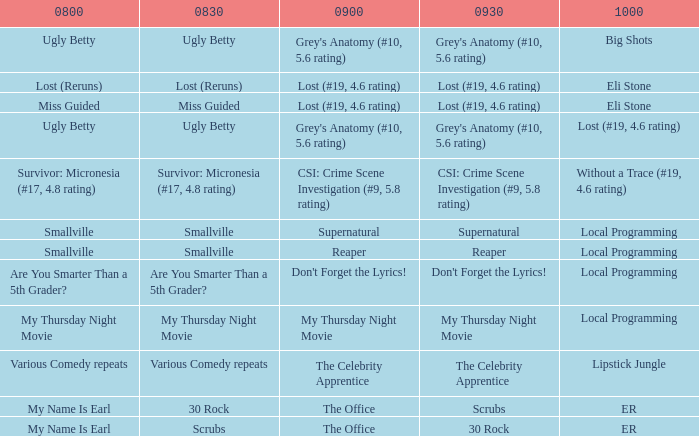What is at 9:30 when at 8:30 it is scrubs? 30 Rock. Could you parse the entire table as a dict? {'header': ['0800', '0830', '0900', '0930', '1000'], 'rows': [['Ugly Betty', 'Ugly Betty', "Grey's Anatomy (#10, 5.6 rating)", "Grey's Anatomy (#10, 5.6 rating)", 'Big Shots'], ['Lost (Reruns)', 'Lost (Reruns)', 'Lost (#19, 4.6 rating)', 'Lost (#19, 4.6 rating)', 'Eli Stone'], ['Miss Guided', 'Miss Guided', 'Lost (#19, 4.6 rating)', 'Lost (#19, 4.6 rating)', 'Eli Stone'], ['Ugly Betty', 'Ugly Betty', "Grey's Anatomy (#10, 5.6 rating)", "Grey's Anatomy (#10, 5.6 rating)", 'Lost (#19, 4.6 rating)'], ['Survivor: Micronesia (#17, 4.8 rating)', 'Survivor: Micronesia (#17, 4.8 rating)', 'CSI: Crime Scene Investigation (#9, 5.8 rating)', 'CSI: Crime Scene Investigation (#9, 5.8 rating)', 'Without a Trace (#19, 4.6 rating)'], ['Smallville', 'Smallville', 'Supernatural', 'Supernatural', 'Local Programming'], ['Smallville', 'Smallville', 'Reaper', 'Reaper', 'Local Programming'], ['Are You Smarter Than a 5th Grader?', 'Are You Smarter Than a 5th Grader?', "Don't Forget the Lyrics!", "Don't Forget the Lyrics!", 'Local Programming'], ['My Thursday Night Movie', 'My Thursday Night Movie', 'My Thursday Night Movie', 'My Thursday Night Movie', 'Local Programming'], ['Various Comedy repeats', 'Various Comedy repeats', 'The Celebrity Apprentice', 'The Celebrity Apprentice', 'Lipstick Jungle'], ['My Name Is Earl', '30 Rock', 'The Office', 'Scrubs', 'ER'], ['My Name Is Earl', 'Scrubs', 'The Office', '30 Rock', 'ER']]} 